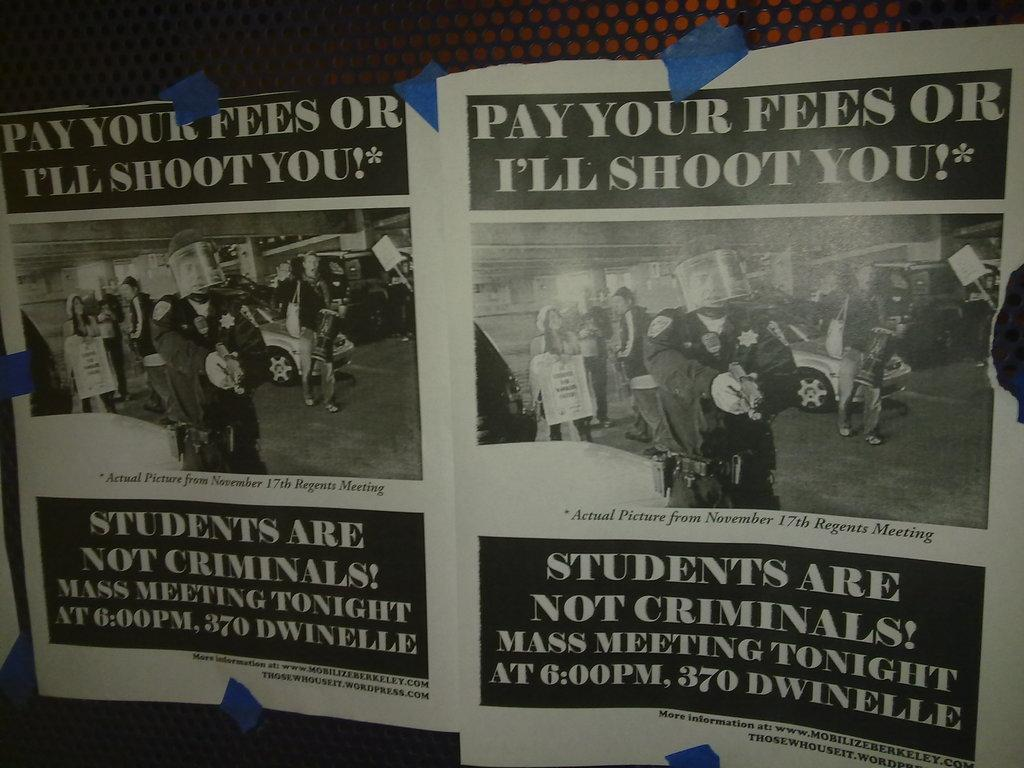<image>
Describe the image concisely. A meeting is taking place tonight at 370 Dwinelle. 